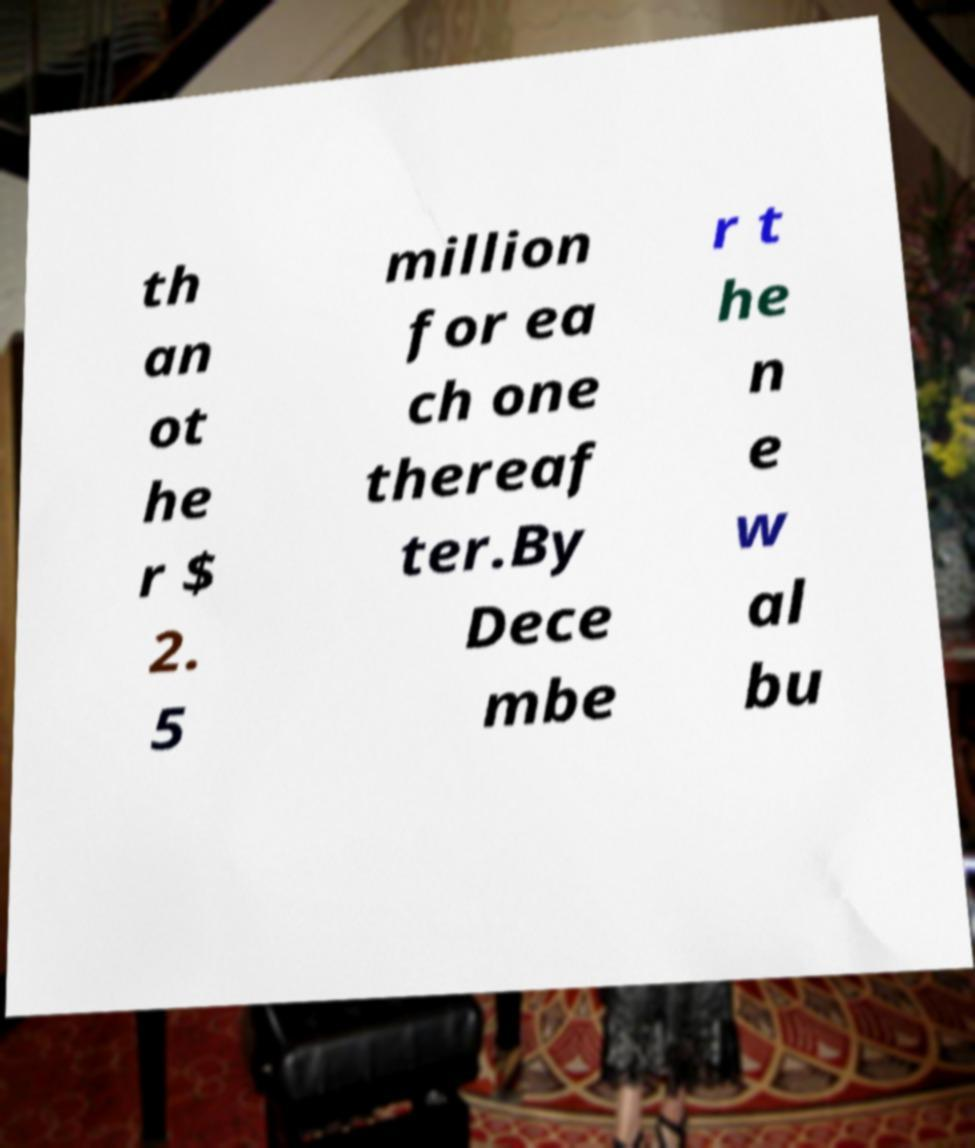There's text embedded in this image that I need extracted. Can you transcribe it verbatim? th an ot he r $ 2. 5 million for ea ch one thereaf ter.By Dece mbe r t he n e w al bu 